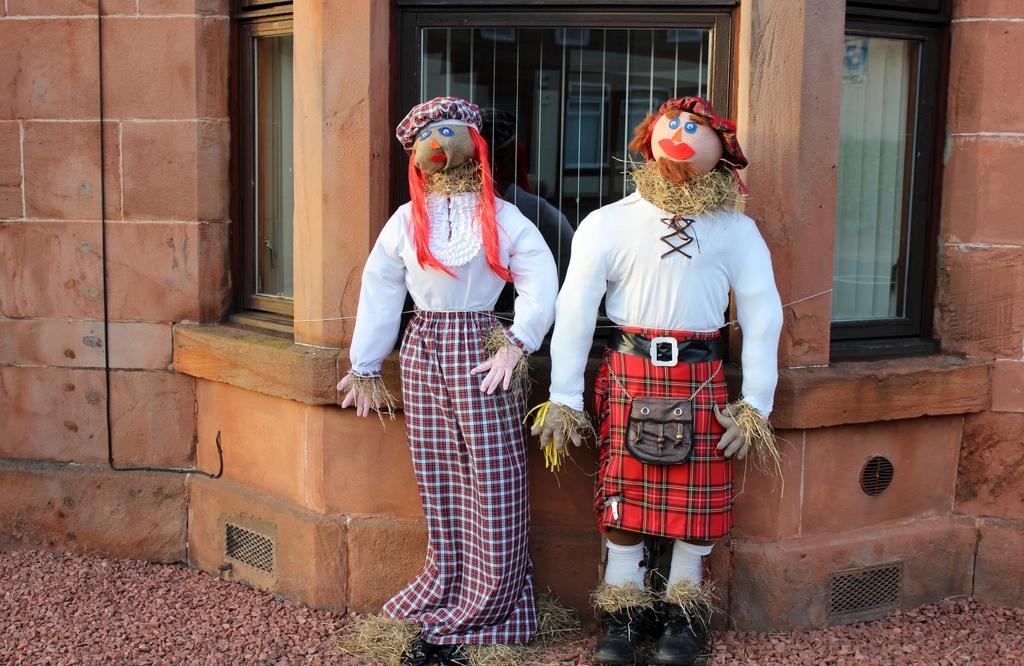Please provide a concise description of this image. In the foreground of this image, there are two scarecrows. Behind it, there are windows and the wall. 